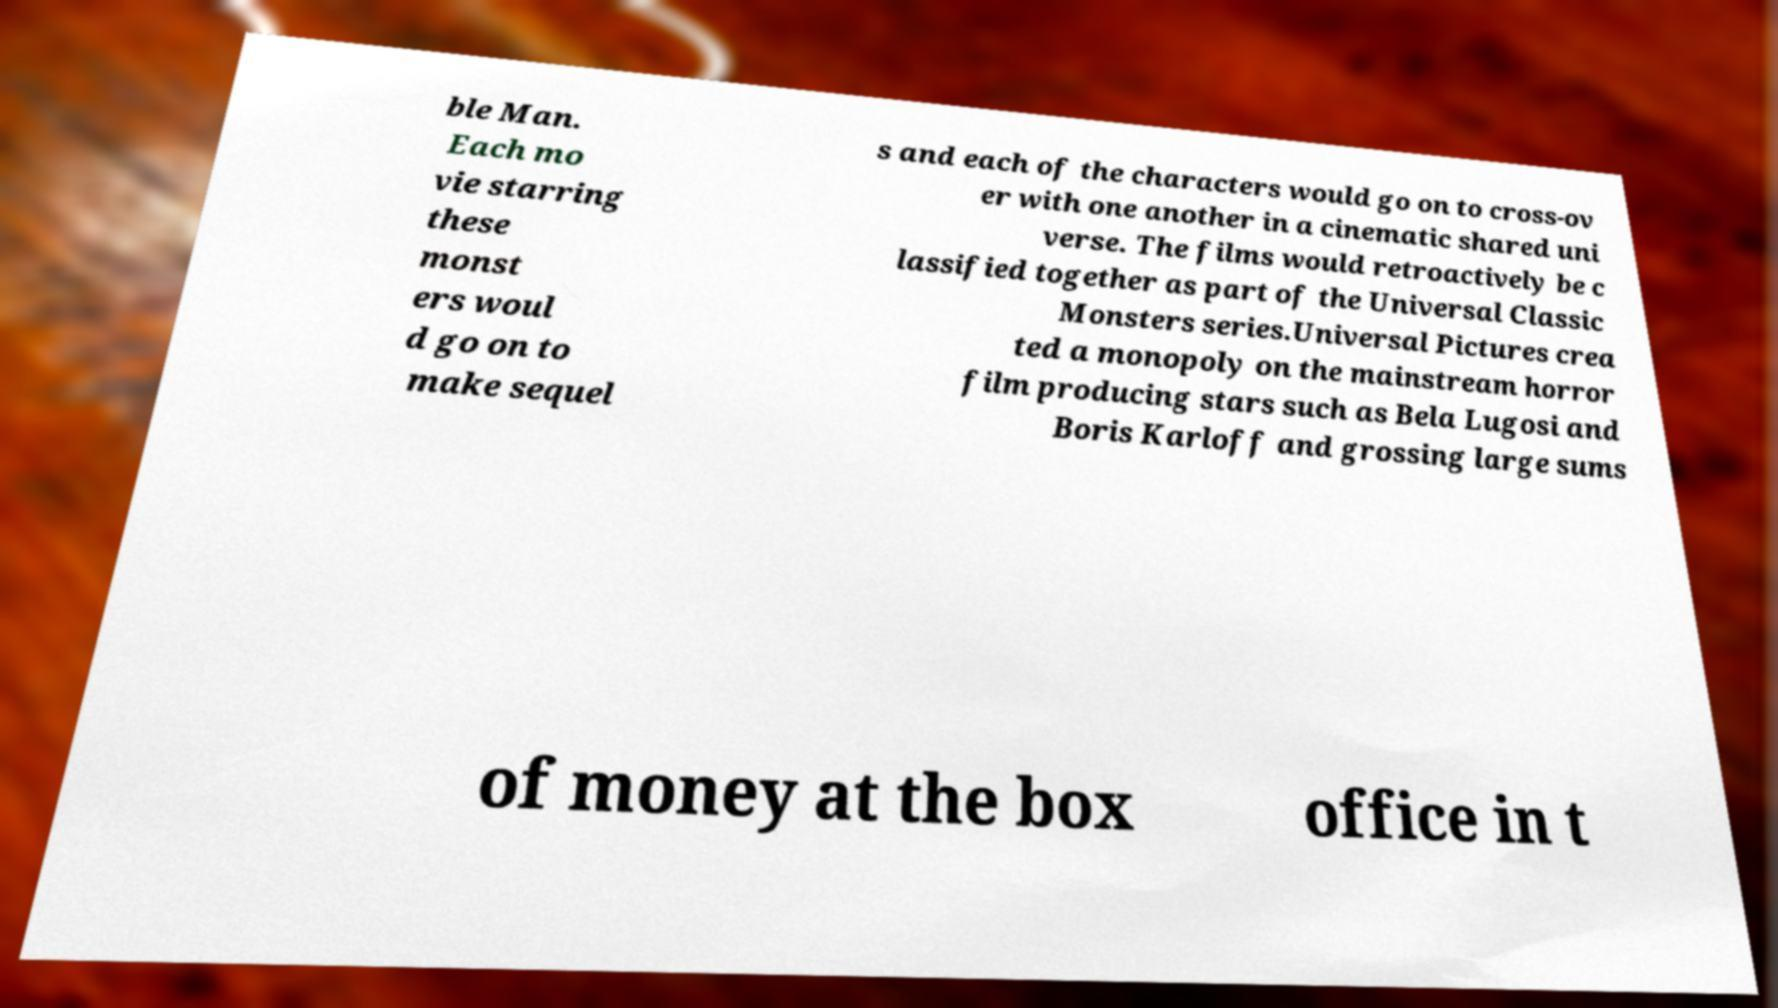Please identify and transcribe the text found in this image. ble Man. Each mo vie starring these monst ers woul d go on to make sequel s and each of the characters would go on to cross-ov er with one another in a cinematic shared uni verse. The films would retroactively be c lassified together as part of the Universal Classic Monsters series.Universal Pictures crea ted a monopoly on the mainstream horror film producing stars such as Bela Lugosi and Boris Karloff and grossing large sums of money at the box office in t 